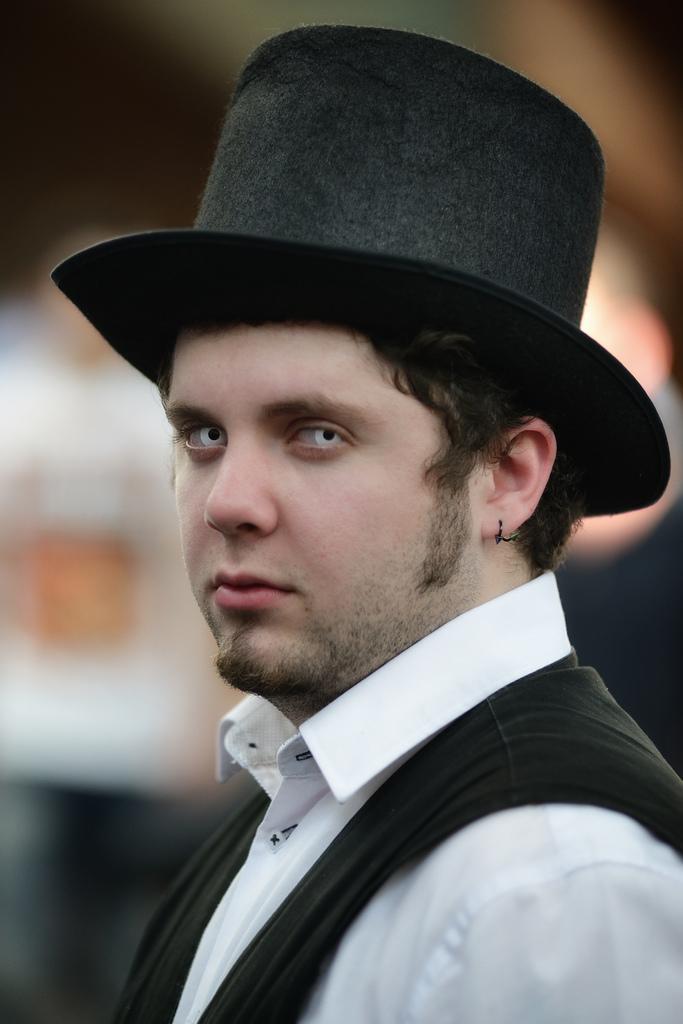Can you describe this image briefly? In this picture I can see there is a man standing and he is wearing a white shirt and a black coat and a hat. In the backdrop there are two people in the standing and it is blurred. 